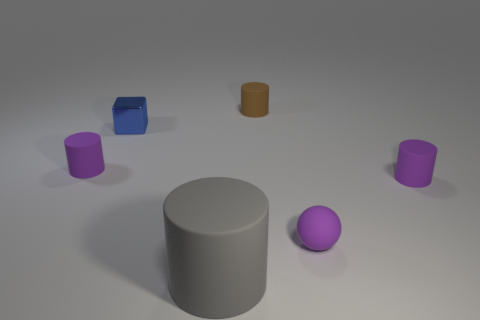How many tiny brown objects have the same shape as the big matte thing?
Your response must be concise. 1. What is the material of the tiny purple cylinder that is in front of the small object left of the blue block?
Your answer should be compact. Rubber. There is a rubber object on the left side of the big gray rubber thing; what is its size?
Offer a terse response. Small. What number of yellow things are metallic things or big cylinders?
Your answer should be very brief. 0. Are there any other things that are made of the same material as the blue object?
Offer a terse response. No. What material is the brown thing that is the same shape as the gray object?
Ensure brevity in your answer.  Rubber. Are there the same number of gray objects that are behind the large gray rubber object and gray rubber blocks?
Offer a very short reply. Yes. There is a purple object that is behind the ball and right of the big gray matte cylinder; how big is it?
Make the answer very short. Small. Is there anything else that has the same color as the rubber sphere?
Provide a short and direct response. Yes. How big is the purple matte object behind the tiny cylinder right of the tiny purple sphere?
Offer a very short reply. Small. 